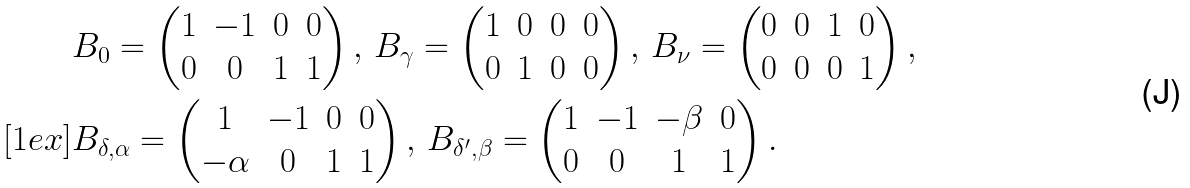Convert formula to latex. <formula><loc_0><loc_0><loc_500><loc_500>& B _ { 0 } = \begin{pmatrix} 1 & - 1 & 0 & 0 \\ 0 & 0 & 1 & 1 \end{pmatrix} , \, B _ { \gamma } = \begin{pmatrix} 1 & 0 & 0 & 0 \\ 0 & 1 & 0 & 0 \end{pmatrix} , \, B _ { \nu } = \begin{pmatrix} 0 & 0 & 1 & 0 \\ 0 & 0 & 0 & 1 \end{pmatrix} , \\ [ 1 e x ] & B _ { \delta , \alpha } = \begin{pmatrix} 1 & - 1 & 0 & 0 \\ - \alpha & 0 & 1 & 1 \end{pmatrix} , \, B _ { \delta ^ { \prime } , \beta } = \begin{pmatrix} 1 & - 1 & - \beta & 0 \\ 0 & 0 & 1 & 1 \end{pmatrix} .</formula> 